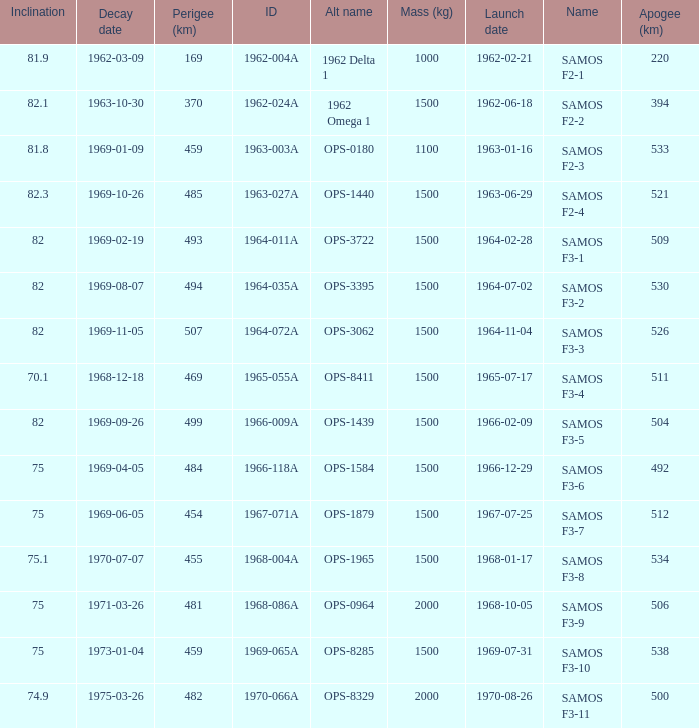What is the maximum apogee for samos f3-3? 526.0. 